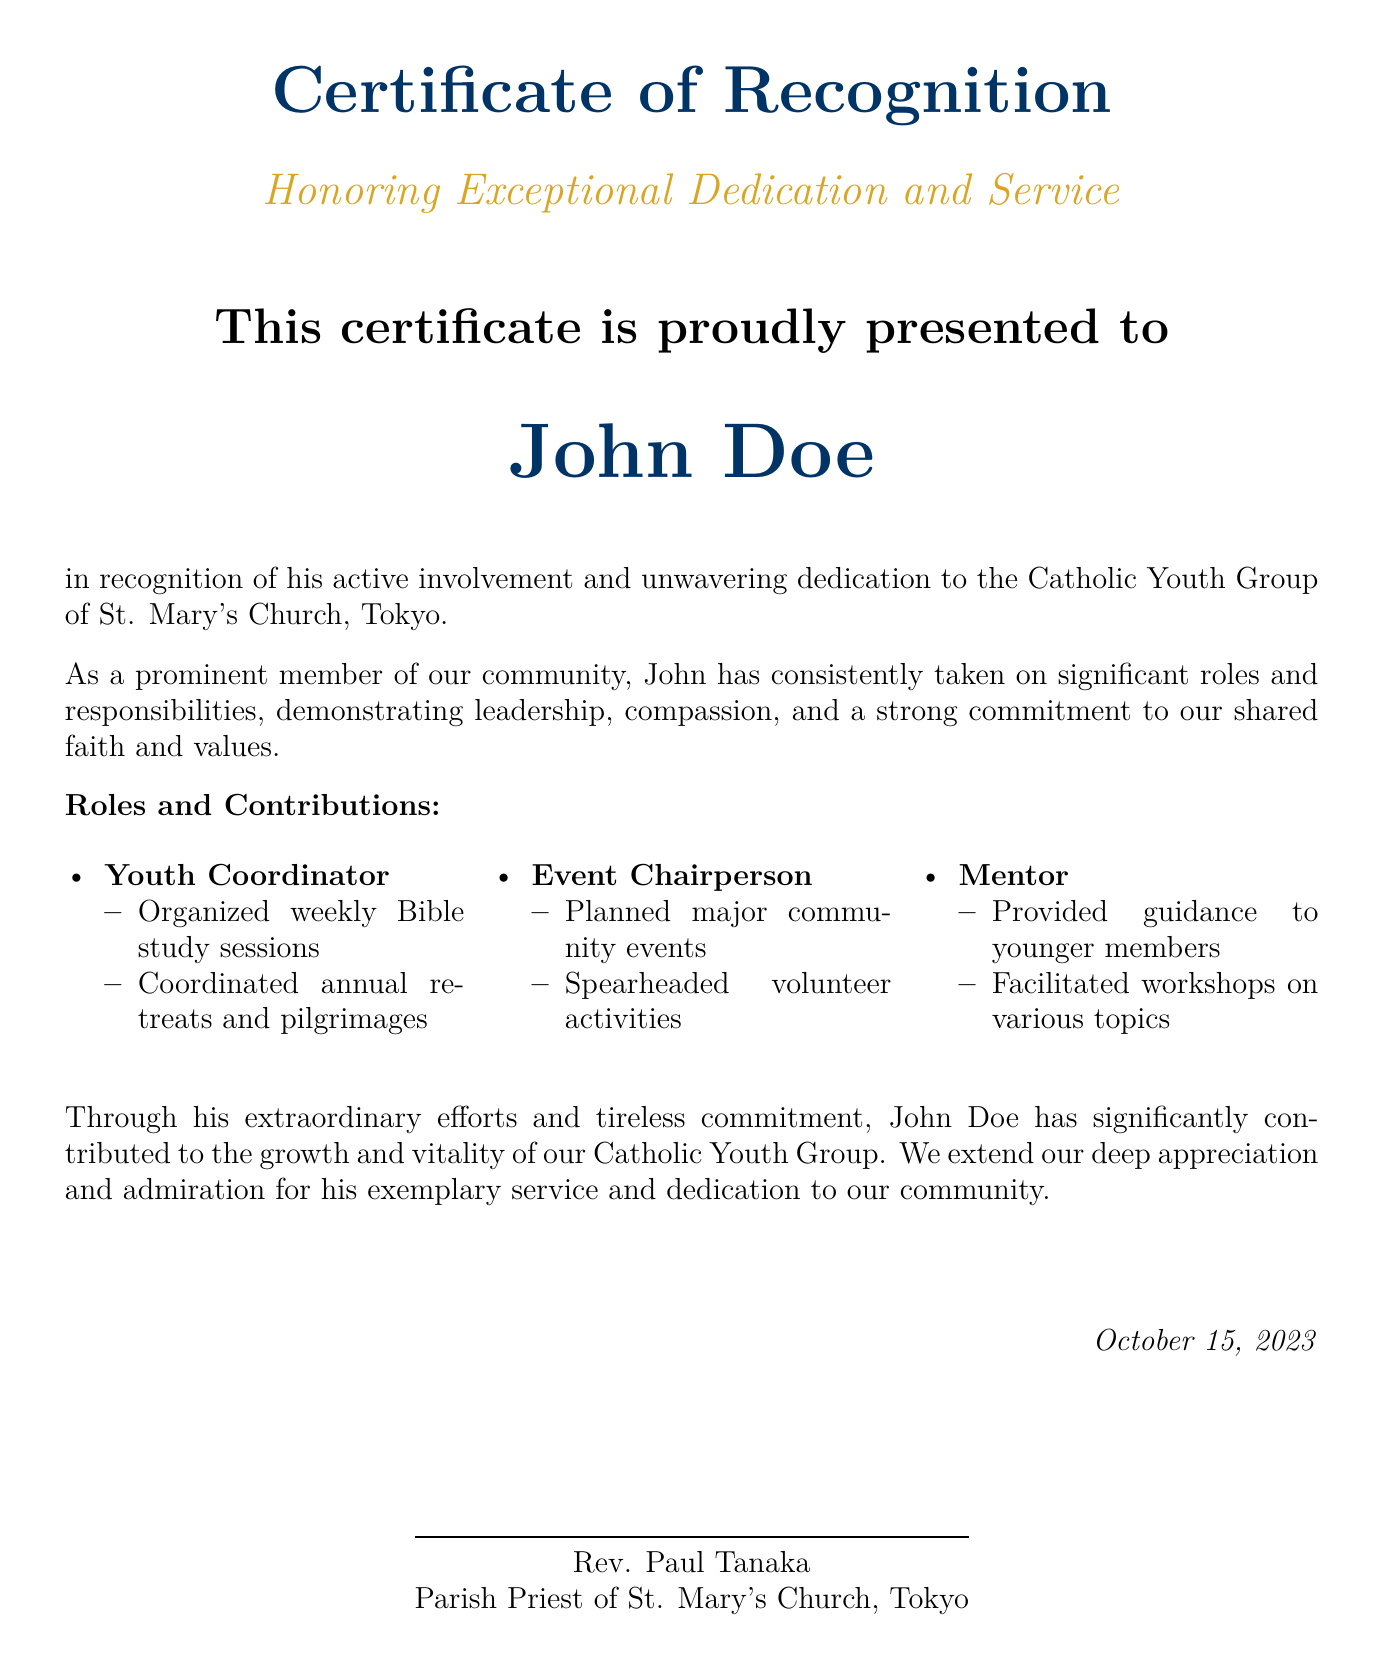What is the title of the document? The title is prominently displayed at the top of the document.
Answer: Certificate of Recognition Who is the recipient of the certificate? The recipient's name is mentioned in a larger font in the center of the document.
Answer: John Doe What is the date on the certificate? The date is located at the bottom right corner of the document.
Answer: October 15, 2023 What is one of the roles listed in the contributions? This role is specified in the "Roles and Contributions" section of the document.
Answer: Youth Coordinator What major event did John Doe help organize as Event Chairperson? The events planned are mentioned in the contributions section.
Answer: Major community events Who issued the certificate? The issuer's name is found in the lower section of the document.
Answer: Rev. Paul Tanaka What type of activities did John coordinate? The type of activities is specified under his role in the contributions section.
Answer: Bible study sessions Why is John Doe being recognized? This is addressed in the opening paragraph of the document.
Answer: Active involvement and unwavering dedication What type of workshops did John facilitate? This detail is included in the description under his role as Mentor.
Answer: Various topics 